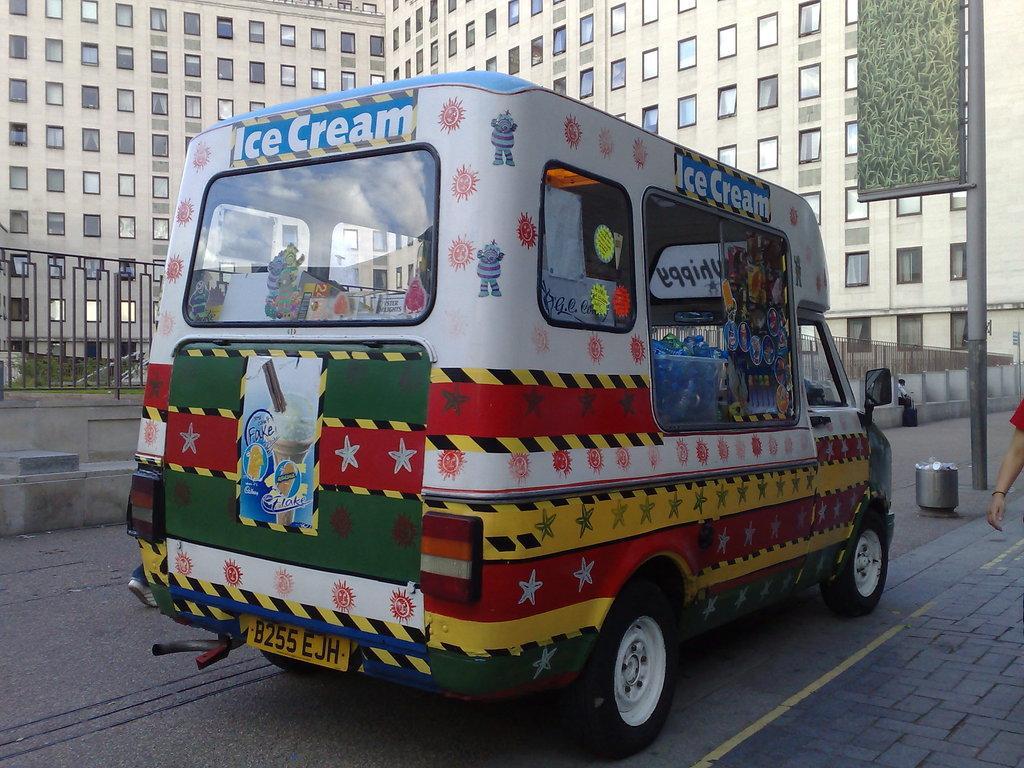How would you summarize this image in a sentence or two? In this image, we can see an ice cream van, on the right side, we can see a pole, we can see the hand of a person, there are some buildings, we can see the windows on the buildings, there is a fence on the left side. 